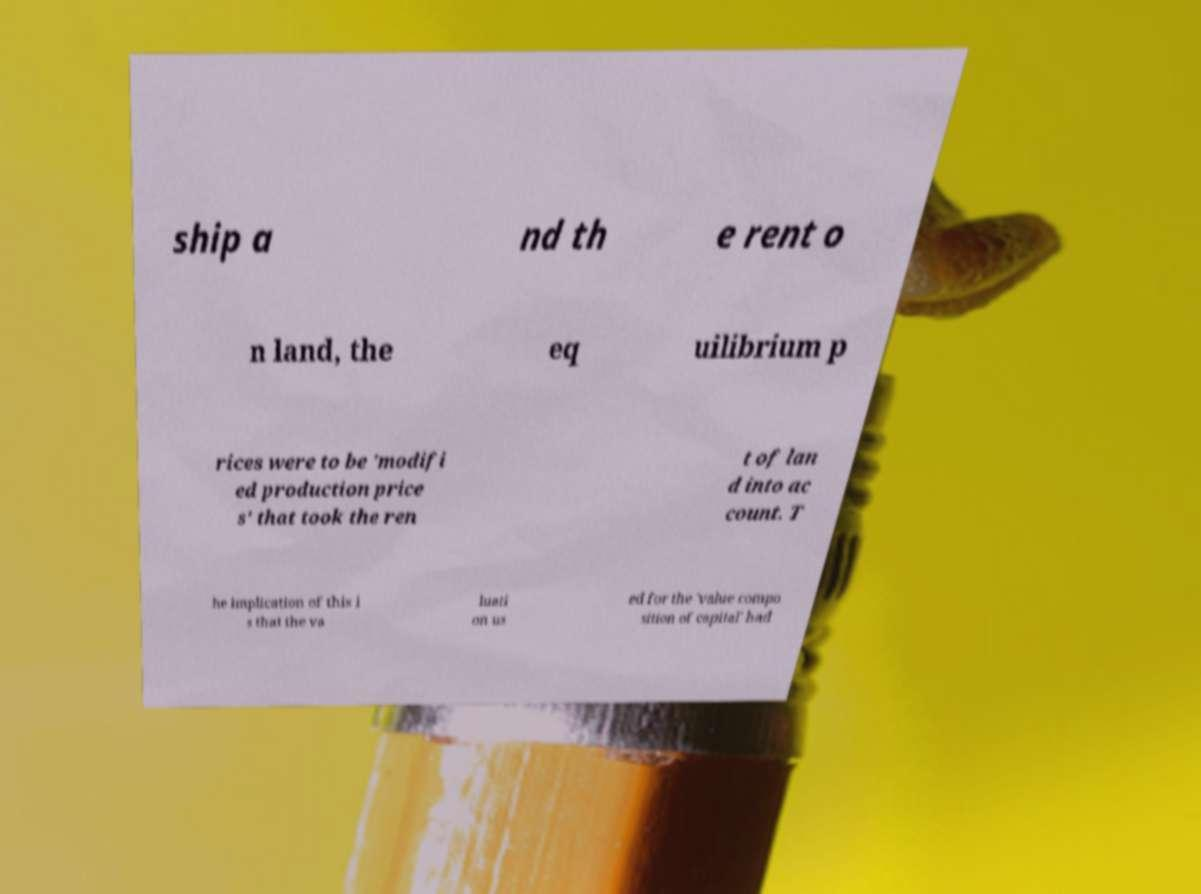Could you assist in decoding the text presented in this image and type it out clearly? ship a nd th e rent o n land, the eq uilibrium p rices were to be 'modifi ed production price s' that took the ren t of lan d into ac count. T he implication of this i s that the va luati on us ed for the 'value compo sition of capital' had 